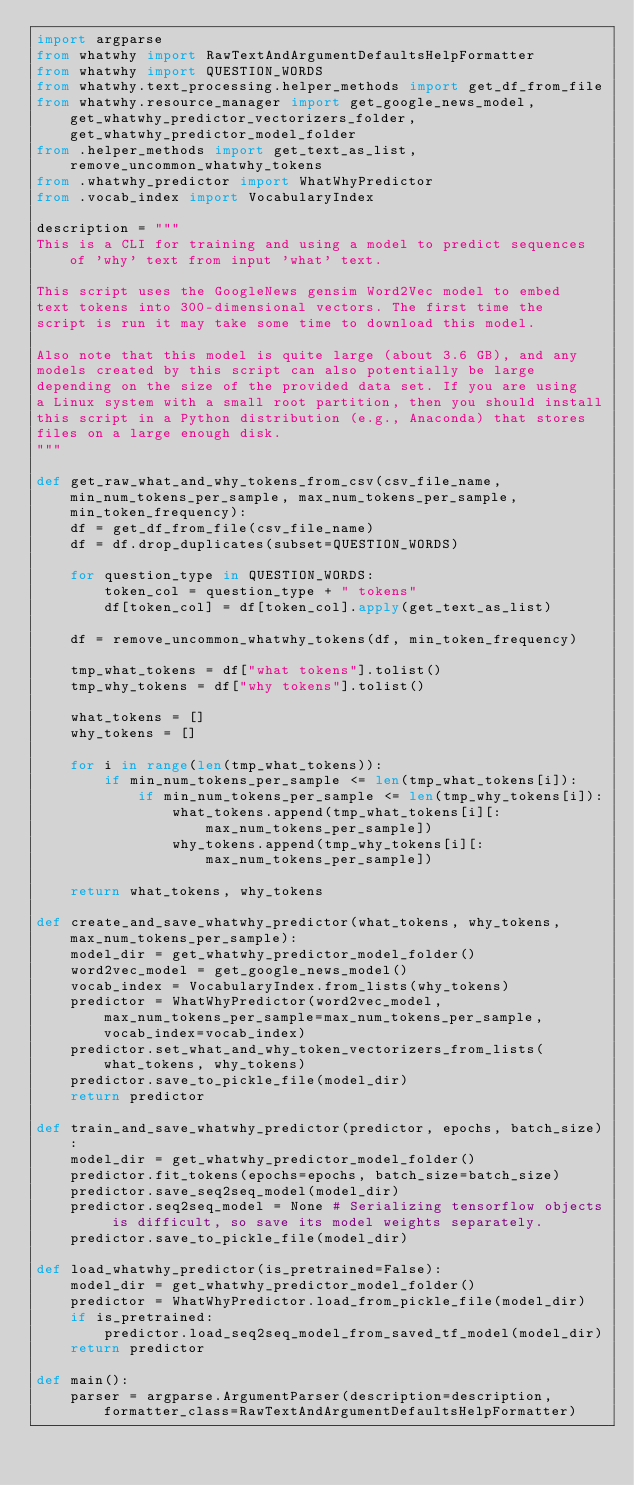<code> <loc_0><loc_0><loc_500><loc_500><_Python_>import argparse
from whatwhy import RawTextAndArgumentDefaultsHelpFormatter
from whatwhy import QUESTION_WORDS
from whatwhy.text_processing.helper_methods import get_df_from_file
from whatwhy.resource_manager import get_google_news_model, get_whatwhy_predictor_vectorizers_folder, get_whatwhy_predictor_model_folder
from .helper_methods import get_text_as_list, remove_uncommon_whatwhy_tokens
from .whatwhy_predictor import WhatWhyPredictor
from .vocab_index import VocabularyIndex

description = """
This is a CLI for training and using a model to predict sequences of 'why' text from input 'what' text.

This script uses the GoogleNews gensim Word2Vec model to embed
text tokens into 300-dimensional vectors. The first time the
script is run it may take some time to download this model.

Also note that this model is quite large (about 3.6 GB), and any
models created by this script can also potentially be large
depending on the size of the provided data set. If you are using
a Linux system with a small root partition, then you should install
this script in a Python distribution (e.g., Anaconda) that stores
files on a large enough disk.
"""

def get_raw_what_and_why_tokens_from_csv(csv_file_name, min_num_tokens_per_sample, max_num_tokens_per_sample, min_token_frequency):
    df = get_df_from_file(csv_file_name)
    df = df.drop_duplicates(subset=QUESTION_WORDS)

    for question_type in QUESTION_WORDS:
        token_col = question_type + " tokens"
        df[token_col] = df[token_col].apply(get_text_as_list)
    
    df = remove_uncommon_whatwhy_tokens(df, min_token_frequency)

    tmp_what_tokens = df["what tokens"].tolist()
    tmp_why_tokens = df["why tokens"].tolist()

    what_tokens = []
    why_tokens = []

    for i in range(len(tmp_what_tokens)):
        if min_num_tokens_per_sample <= len(tmp_what_tokens[i]):
            if min_num_tokens_per_sample <= len(tmp_why_tokens[i]):
                what_tokens.append(tmp_what_tokens[i][:max_num_tokens_per_sample])
                why_tokens.append(tmp_why_tokens[i][:max_num_tokens_per_sample])

    return what_tokens, why_tokens

def create_and_save_whatwhy_predictor(what_tokens, why_tokens, max_num_tokens_per_sample):
    model_dir = get_whatwhy_predictor_model_folder()
    word2vec_model = get_google_news_model()
    vocab_index = VocabularyIndex.from_lists(why_tokens)
    predictor = WhatWhyPredictor(word2vec_model, max_num_tokens_per_sample=max_num_tokens_per_sample, vocab_index=vocab_index)
    predictor.set_what_and_why_token_vectorizers_from_lists(what_tokens, why_tokens)
    predictor.save_to_pickle_file(model_dir)
    return predictor

def train_and_save_whatwhy_predictor(predictor, epochs, batch_size):
    model_dir = get_whatwhy_predictor_model_folder()
    predictor.fit_tokens(epochs=epochs, batch_size=batch_size)
    predictor.save_seq2seq_model(model_dir)
    predictor.seq2seq_model = None # Serializing tensorflow objects is difficult, so save its model weights separately.
    predictor.save_to_pickle_file(model_dir)

def load_whatwhy_predictor(is_pretrained=False):
    model_dir = get_whatwhy_predictor_model_folder()
    predictor = WhatWhyPredictor.load_from_pickle_file(model_dir)
    if is_pretrained:
        predictor.load_seq2seq_model_from_saved_tf_model(model_dir)
    return predictor

def main():
    parser = argparse.ArgumentParser(description=description, formatter_class=RawTextAndArgumentDefaultsHelpFormatter)</code> 